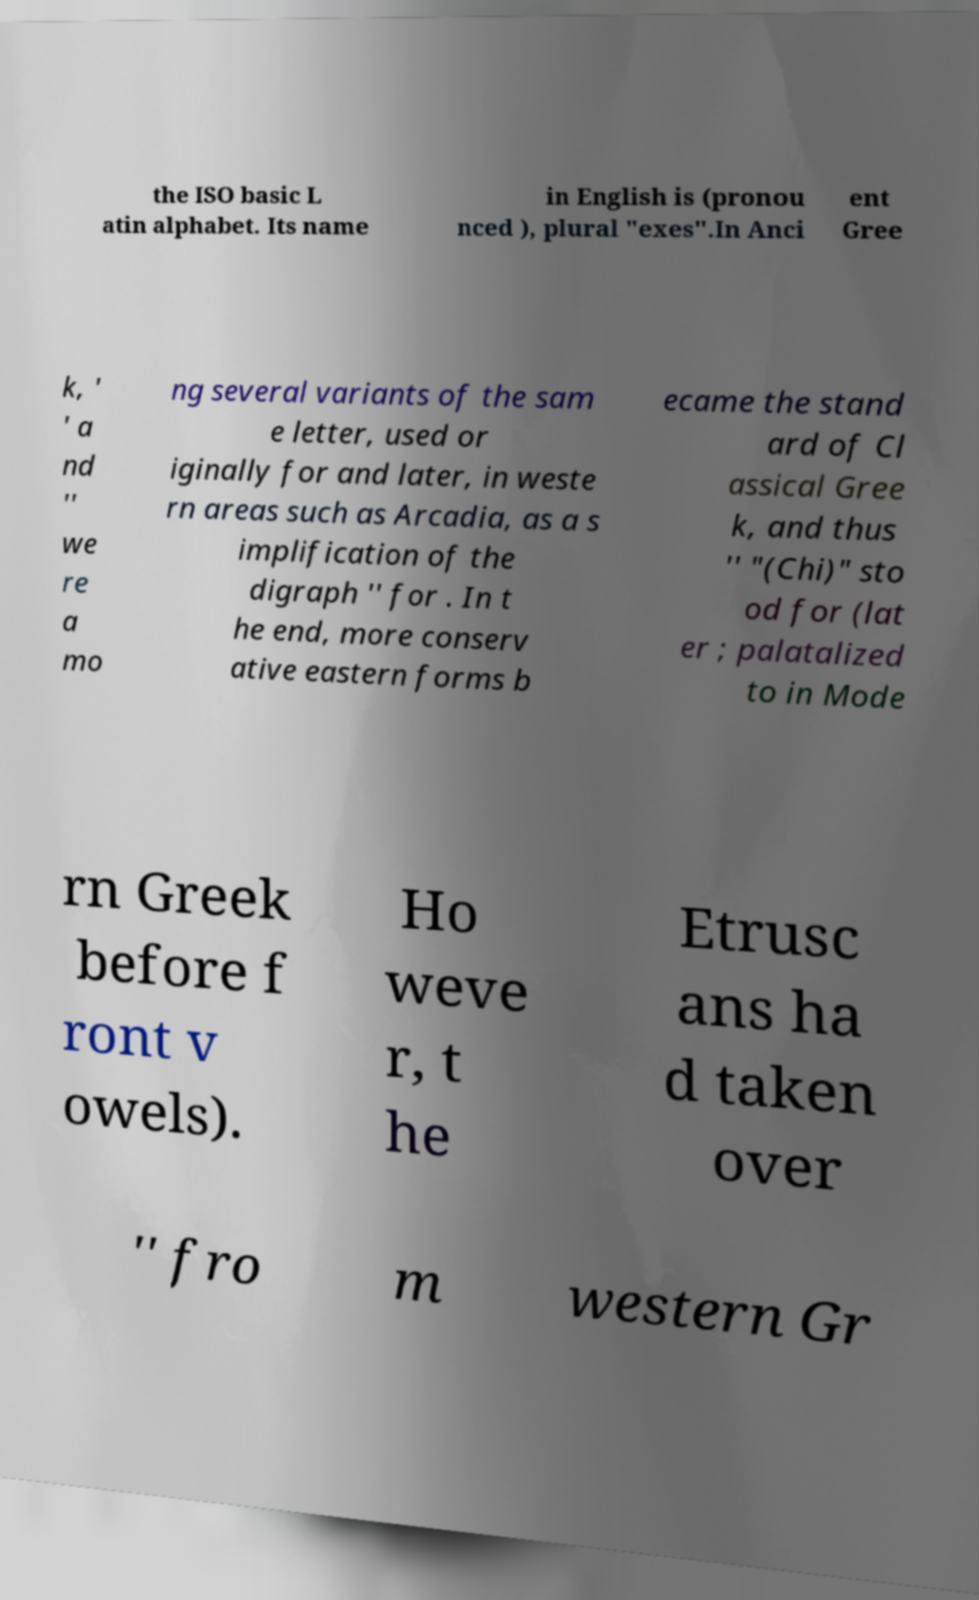Could you extract and type out the text from this image? the ISO basic L atin alphabet. Its name in English is (pronou nced ), plural "exes".In Anci ent Gree k, ' ' a nd '' we re a mo ng several variants of the sam e letter, used or iginally for and later, in weste rn areas such as Arcadia, as a s implification of the digraph '' for . In t he end, more conserv ative eastern forms b ecame the stand ard of Cl assical Gree k, and thus '' "(Chi)" sto od for (lat er ; palatalized to in Mode rn Greek before f ront v owels). Ho weve r, t he Etrusc ans ha d taken over '' fro m western Gr 